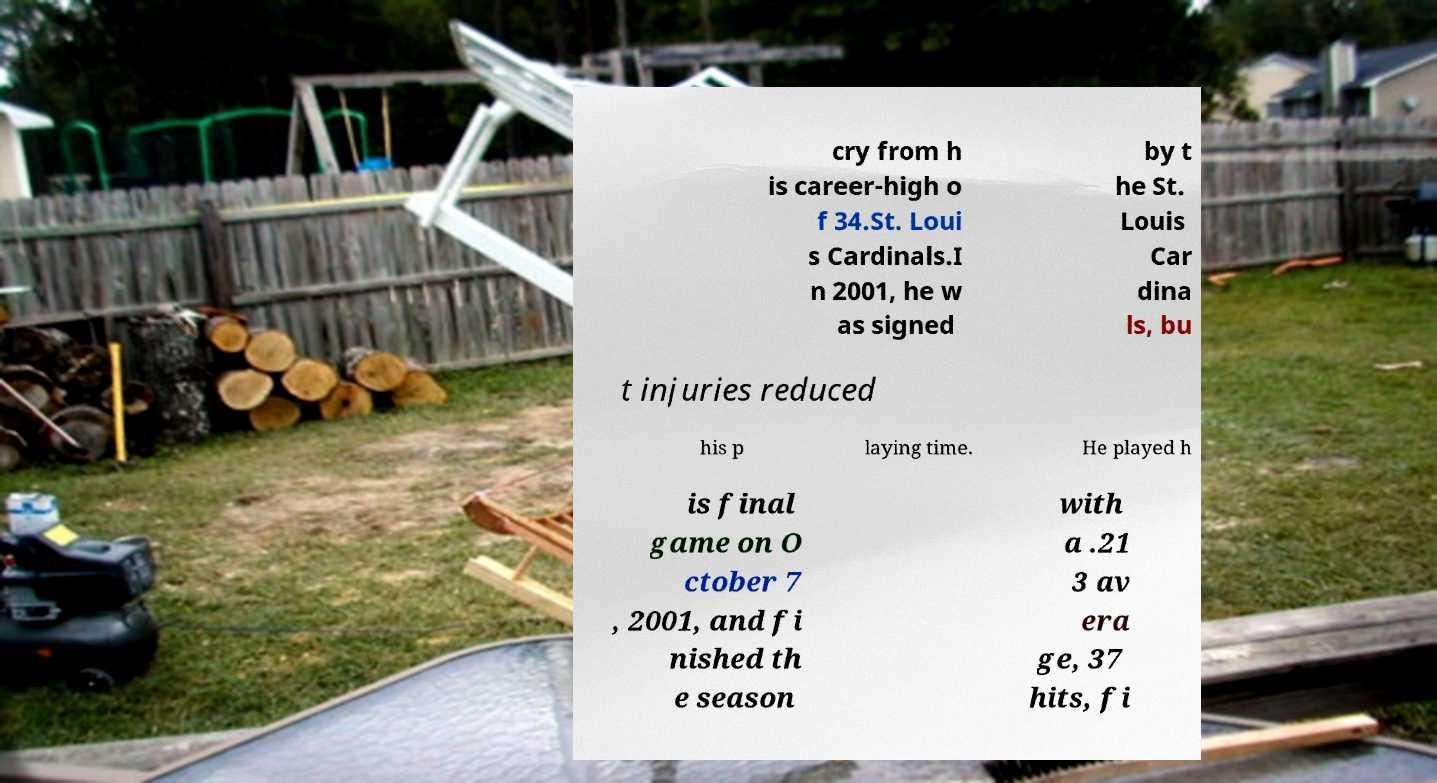Could you assist in decoding the text presented in this image and type it out clearly? cry from h is career-high o f 34.St. Loui s Cardinals.I n 2001, he w as signed by t he St. Louis Car dina ls, bu t injuries reduced his p laying time. He played h is final game on O ctober 7 , 2001, and fi nished th e season with a .21 3 av era ge, 37 hits, fi 